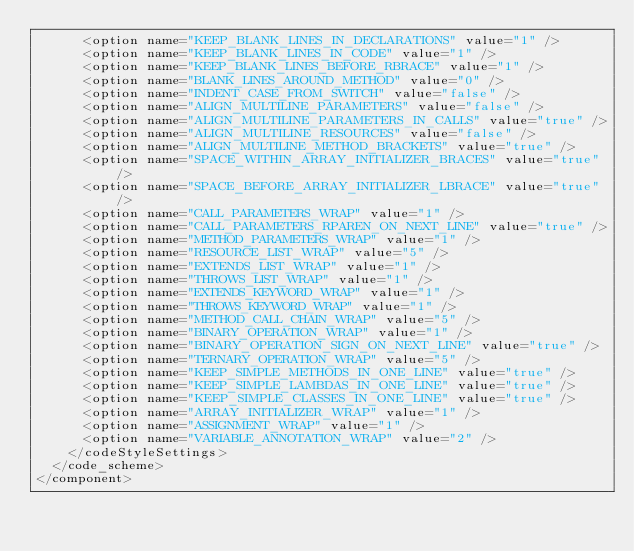Convert code to text. <code><loc_0><loc_0><loc_500><loc_500><_XML_>      <option name="KEEP_BLANK_LINES_IN_DECLARATIONS" value="1" />
      <option name="KEEP_BLANK_LINES_IN_CODE" value="1" />
      <option name="KEEP_BLANK_LINES_BEFORE_RBRACE" value="1" />
      <option name="BLANK_LINES_AROUND_METHOD" value="0" />
      <option name="INDENT_CASE_FROM_SWITCH" value="false" />
      <option name="ALIGN_MULTILINE_PARAMETERS" value="false" />
      <option name="ALIGN_MULTILINE_PARAMETERS_IN_CALLS" value="true" />
      <option name="ALIGN_MULTILINE_RESOURCES" value="false" />
      <option name="ALIGN_MULTILINE_METHOD_BRACKETS" value="true" />
      <option name="SPACE_WITHIN_ARRAY_INITIALIZER_BRACES" value="true" />
      <option name="SPACE_BEFORE_ARRAY_INITIALIZER_LBRACE" value="true" />
      <option name="CALL_PARAMETERS_WRAP" value="1" />
      <option name="CALL_PARAMETERS_RPAREN_ON_NEXT_LINE" value="true" />
      <option name="METHOD_PARAMETERS_WRAP" value="1" />
      <option name="RESOURCE_LIST_WRAP" value="5" />
      <option name="EXTENDS_LIST_WRAP" value="1" />
      <option name="THROWS_LIST_WRAP" value="1" />
      <option name="EXTENDS_KEYWORD_WRAP" value="1" />
      <option name="THROWS_KEYWORD_WRAP" value="1" />
      <option name="METHOD_CALL_CHAIN_WRAP" value="5" />
      <option name="BINARY_OPERATION_WRAP" value="1" />
      <option name="BINARY_OPERATION_SIGN_ON_NEXT_LINE" value="true" />
      <option name="TERNARY_OPERATION_WRAP" value="5" />
      <option name="KEEP_SIMPLE_METHODS_IN_ONE_LINE" value="true" />
      <option name="KEEP_SIMPLE_LAMBDAS_IN_ONE_LINE" value="true" />
      <option name="KEEP_SIMPLE_CLASSES_IN_ONE_LINE" value="true" />
      <option name="ARRAY_INITIALIZER_WRAP" value="1" />
      <option name="ASSIGNMENT_WRAP" value="1" />
      <option name="VARIABLE_ANNOTATION_WRAP" value="2" />
    </codeStyleSettings>
  </code_scheme>
</component></code> 